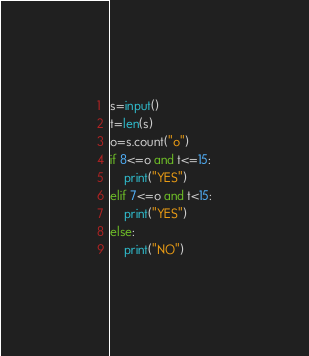<code> <loc_0><loc_0><loc_500><loc_500><_Python_>s=input()
t=len(s)
o=s.count("o")
if 8<=o and t<=15:
    print("YES")
elif 7<=o and t<15:
    print("YES")
else:
    print("NO")</code> 